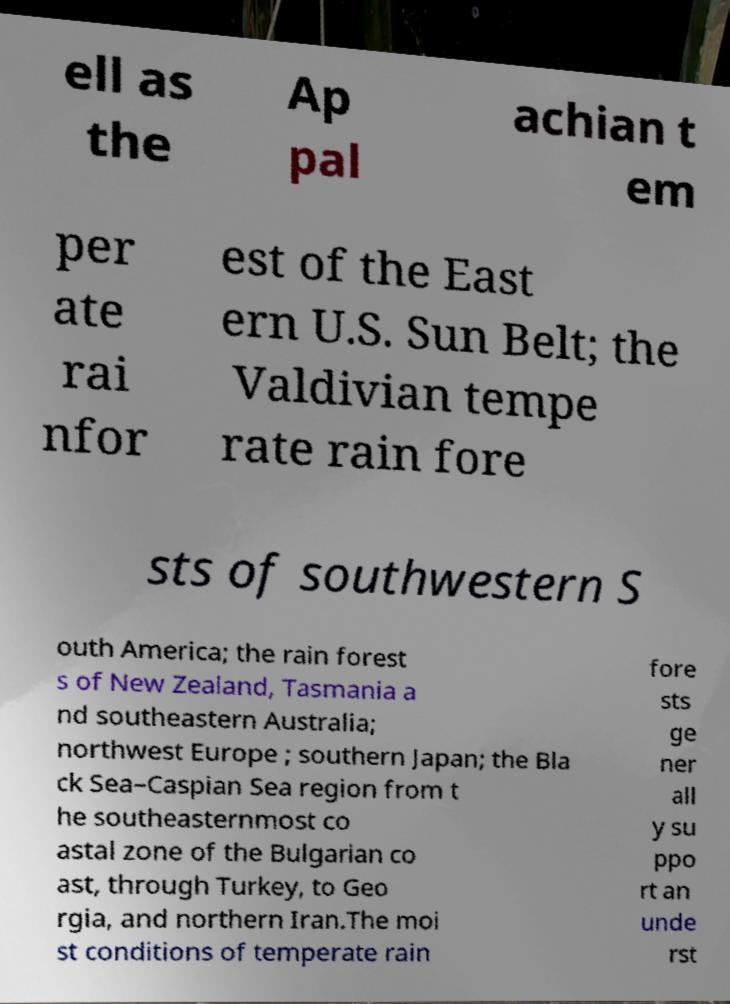What messages or text are displayed in this image? I need them in a readable, typed format. ell as the Ap pal achian t em per ate rai nfor est of the East ern U.S. Sun Belt; the Valdivian tempe rate rain fore sts of southwestern S outh America; the rain forest s of New Zealand, Tasmania a nd southeastern Australia; northwest Europe ; southern Japan; the Bla ck Sea–Caspian Sea region from t he southeasternmost co astal zone of the Bulgarian co ast, through Turkey, to Geo rgia, and northern Iran.The moi st conditions of temperate rain fore sts ge ner all y su ppo rt an unde rst 